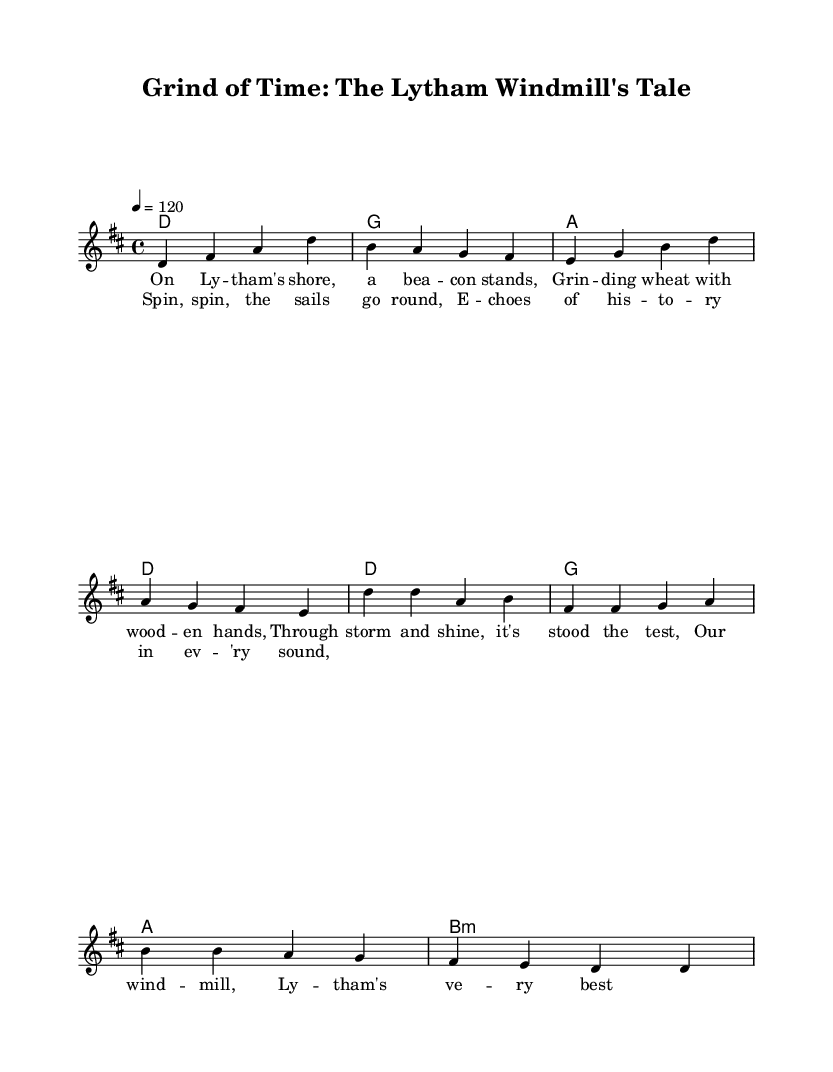What is the key signature of this music? The key signature is D major, which has two sharps (F# and C#). This can be determined by looking at the key signature notation at the beginning of the sheet music.
Answer: D major What is the time signature of this music? The time signature is 4/4, meaning there are four beats in a measure and the quarter note gets one beat. This information is also located at the beginning of the sheet music, right after the key signature.
Answer: 4/4 What is the tempo marking for this music? The tempo marking is 120 beats per minute, indicated by the notation "4 = 120" at the beginning. This specifies how fast the piece should be played.
Answer: 120 How many measures are there in the verse? There are eight measures in the verse, which can be counted by looking at the arrangement of the notes and bars in the melody section.
Answer: 8 What chords are used in the chorus? The chords used in the chorus are D, G, A, and B minor, as indicated in the harmonies section of the sheet music. They define the harmonic structure for the chorus lines.
Answer: D, G, A, B minor In which genre does this music belong? The music belongs to the folk-punk genre, characterized by its blend of folk music elements with punk rock sensibilities. This can be inferred from the style of the lyrics and the overall thematic content.
Answer: Folk-punk What is the lyrical theme of this ballad? The lyrical theme celebrates the legacy of Lytham's windmill, as expressed in the lyrics that reference the windmill and its historical significance. This thematic focus is evident throughout the verses and chorus.
Answer: Legacy of Lytham's windmill 